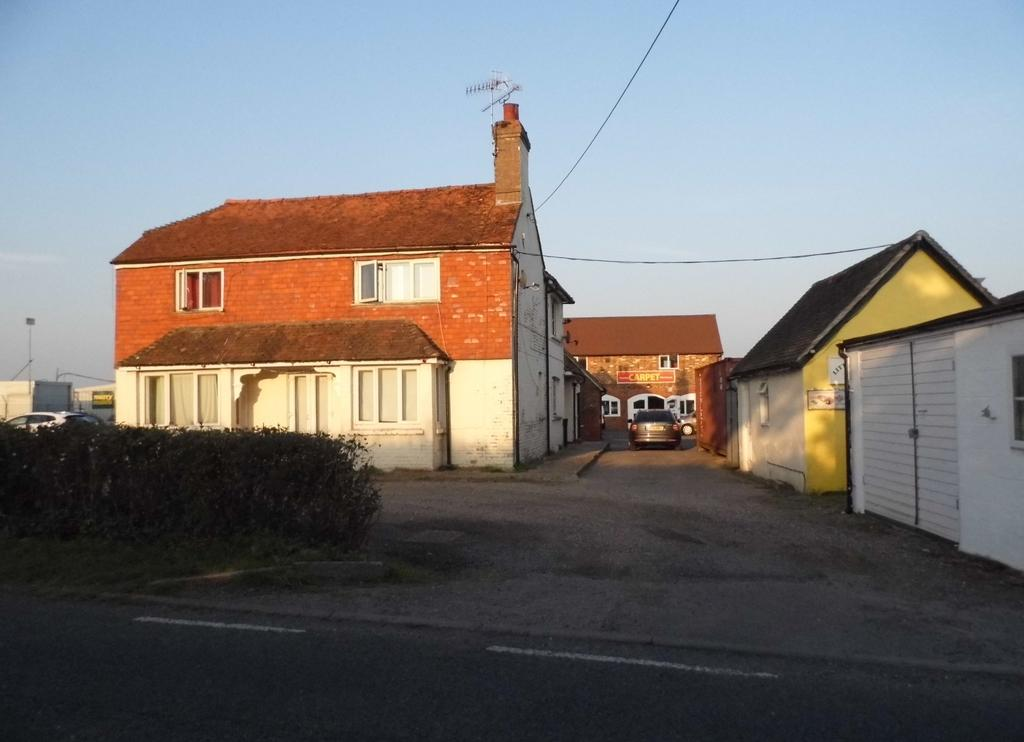What type of structures can be seen in the image? There are houses in the image. What else is present in the image besides houses? There are vehicles, poles, wires, and the ground visible in the image. Can you describe the natural elements in the image? There is grass, plants, and the sky visible in the image. What type of comb is being used to groom the hair in the image? There is no comb or hair present in the image; it features houses, vehicles, poles, wires, the ground, grass, plants, and the sky. 